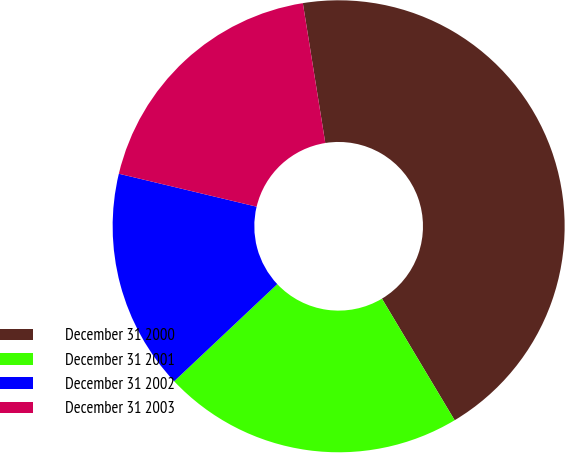<chart> <loc_0><loc_0><loc_500><loc_500><pie_chart><fcel>December 31 2000<fcel>December 31 2001<fcel>December 31 2002<fcel>December 31 2003<nl><fcel>43.95%<fcel>21.55%<fcel>15.76%<fcel>18.73%<nl></chart> 